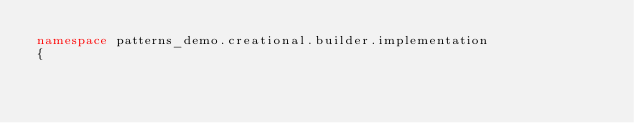Convert code to text. <code><loc_0><loc_0><loc_500><loc_500><_C#_>namespace patterns_demo.creational.builder.implementation
{</code> 